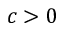Convert formula to latex. <formula><loc_0><loc_0><loc_500><loc_500>c > 0</formula> 